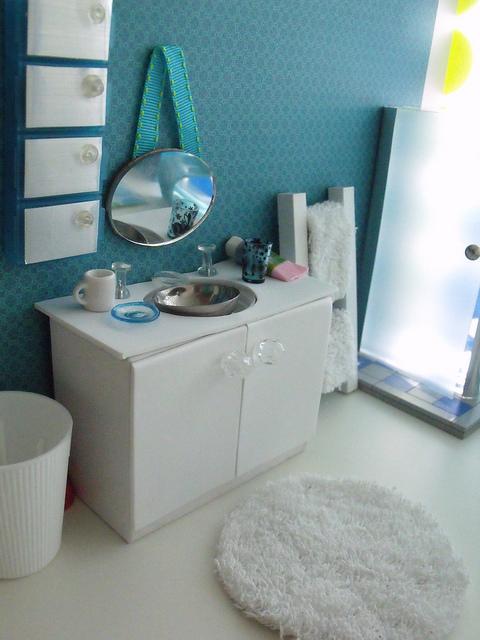Is it night time?
Concise answer only. No. Where is the trash can?
Answer briefly. Left of sink. Is the glass empty?
Short answer required. Yes. Can a human fit into this bathroom?
Short answer required. Yes. What is the color of the rug?
Be succinct. White. 